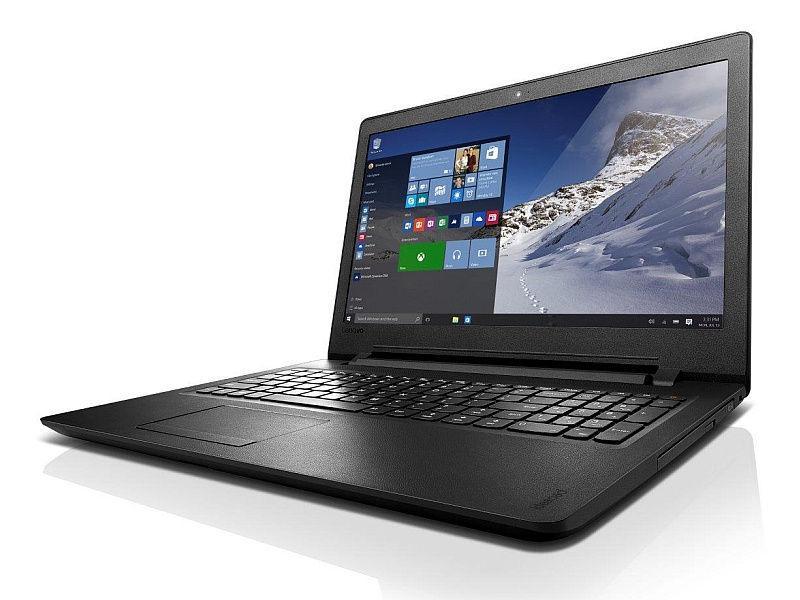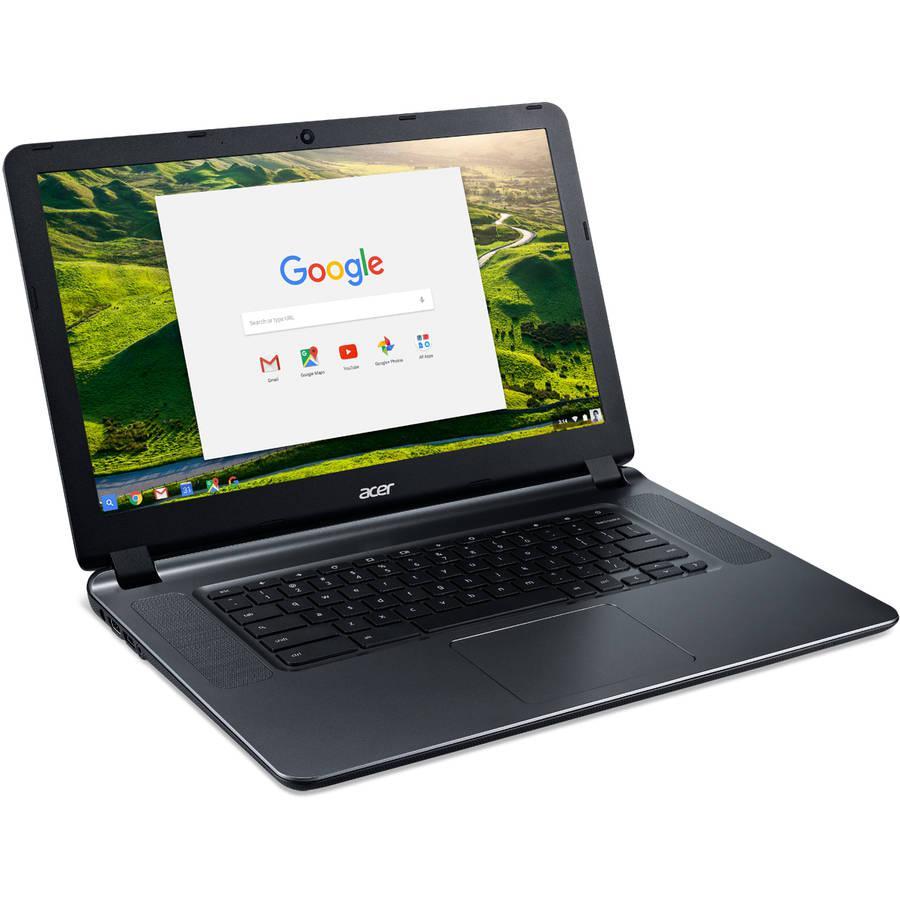The first image is the image on the left, the second image is the image on the right. For the images displayed, is the sentence "The keyboard in the image on the left is black." factually correct? Answer yes or no. Yes. The first image is the image on the left, the second image is the image on the right. Evaluate the accuracy of this statement regarding the images: "One open laptop faces straight forward, and the other is turned at an angle but not held by a hand.". Is it true? Answer yes or no. No. 